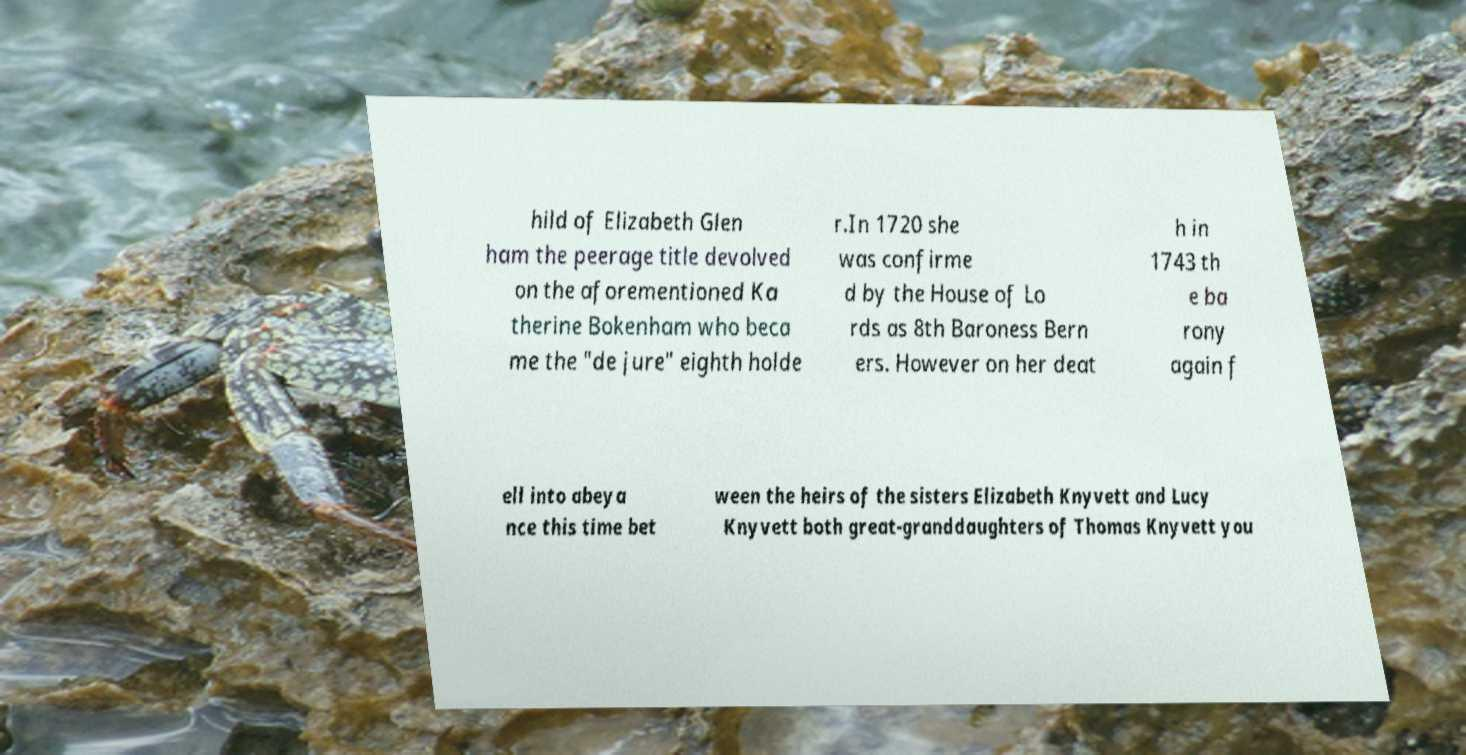Could you assist in decoding the text presented in this image and type it out clearly? hild of Elizabeth Glen ham the peerage title devolved on the aforementioned Ka therine Bokenham who beca me the "de jure" eighth holde r.In 1720 she was confirme d by the House of Lo rds as 8th Baroness Bern ers. However on her deat h in 1743 th e ba rony again f ell into abeya nce this time bet ween the heirs of the sisters Elizabeth Knyvett and Lucy Knyvett both great-granddaughters of Thomas Knyvett you 